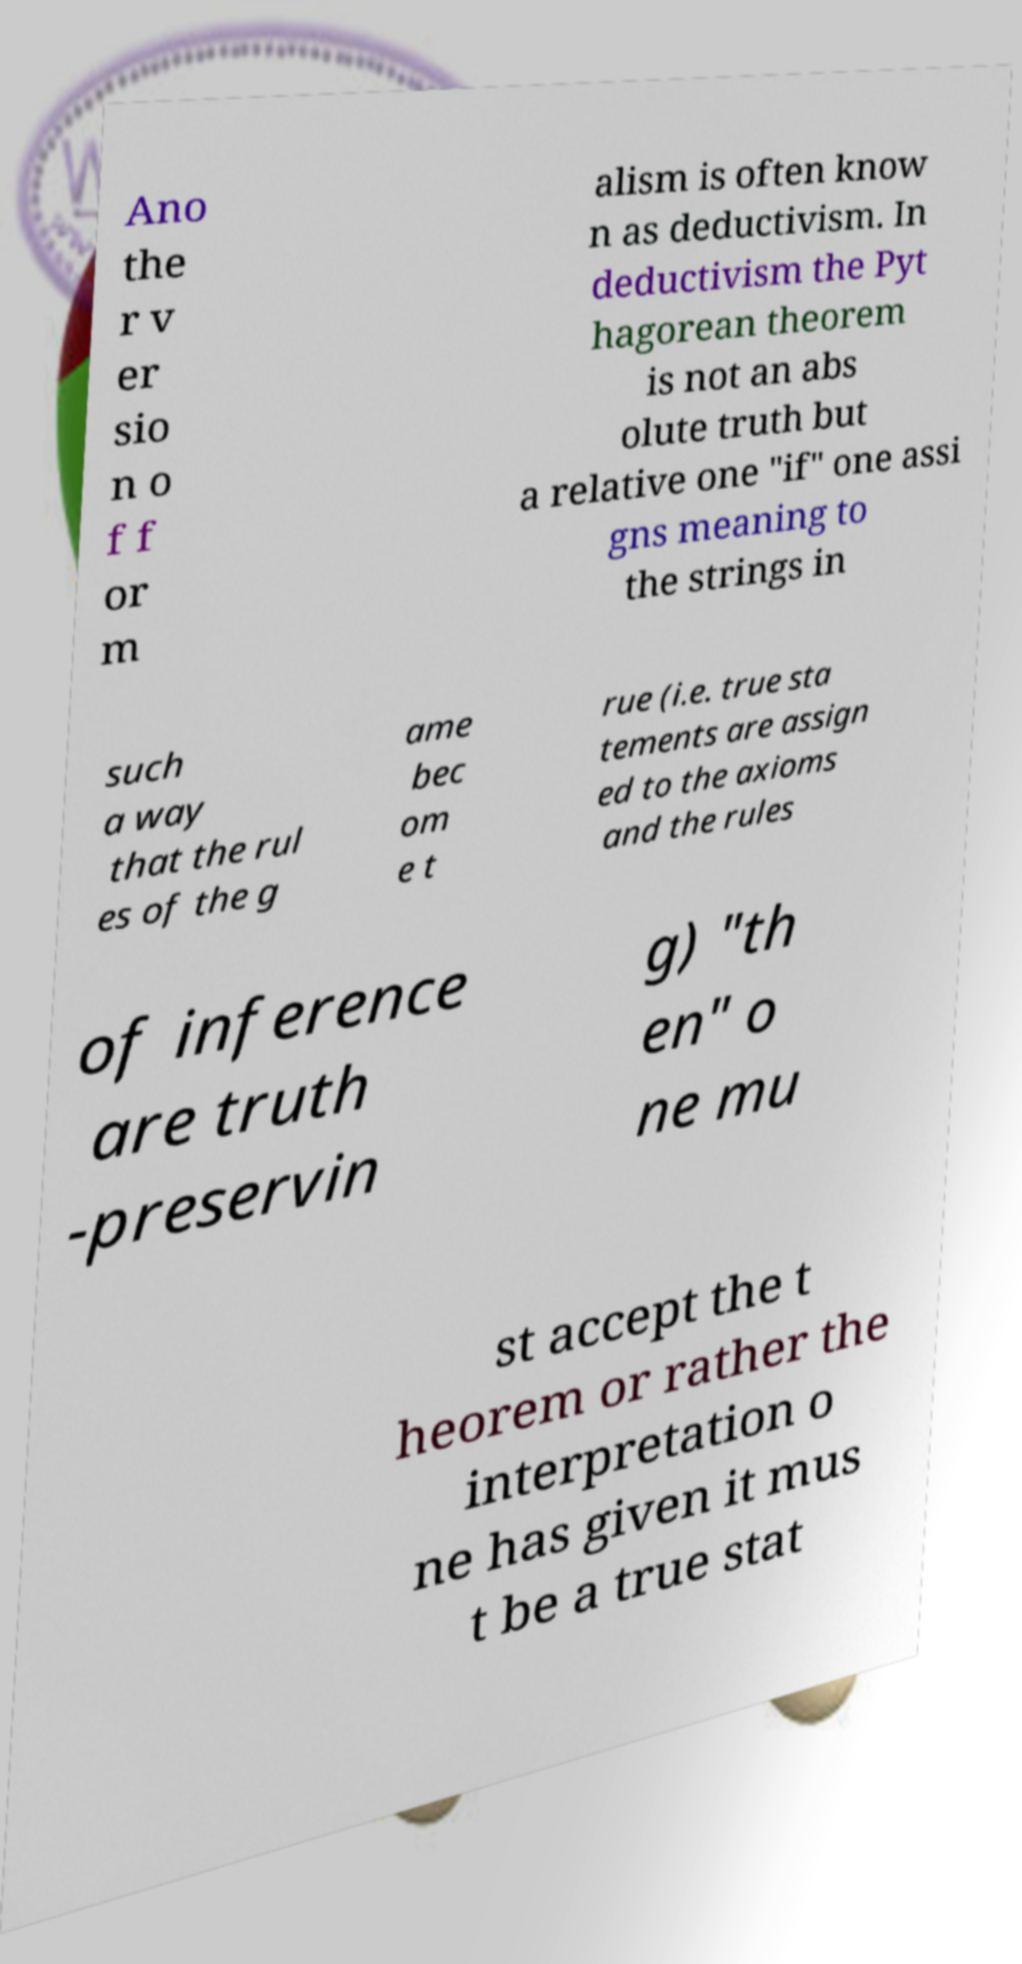Please read and relay the text visible in this image. What does it say? Ano the r v er sio n o f f or m alism is often know n as deductivism. In deductivism the Pyt hagorean theorem is not an abs olute truth but a relative one "if" one assi gns meaning to the strings in such a way that the rul es of the g ame bec om e t rue (i.e. true sta tements are assign ed to the axioms and the rules of inference are truth -preservin g) "th en" o ne mu st accept the t heorem or rather the interpretation o ne has given it mus t be a true stat 